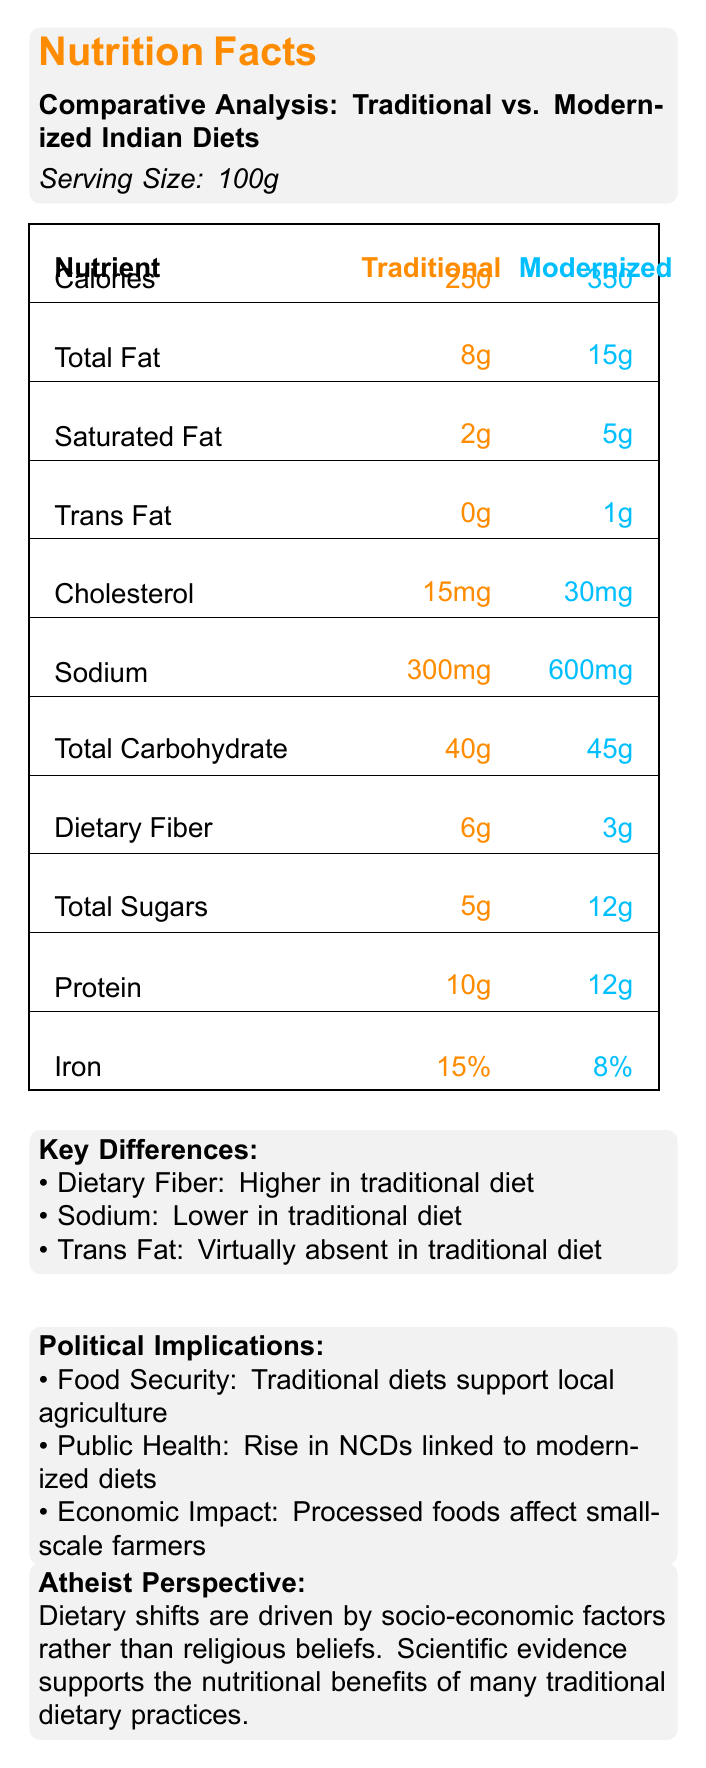what is the serving size for both diets? The document specifies that the serving size for both the traditional and modernized diets is 100g.
Answer: 100g how many calories are in the traditional diet per serving? The document states that the traditional diet contains 250 calories per serving.
Answer: 250 how much total fat is there in the modernized diet per serving? According to the document, the modernized diet contains 15g of total fat per serving.
Answer: 15g which diet has a higher dietary fiber content? The document indicates that the traditional diet has 6g of dietary fiber compared to 3g in the modernized diet.
Answer: Traditional diet what are the traditional dietary staples listed in the document? The document lists these as the traditional staples in the cultural context section.
Answer: Dal (lentils), Roti (whole wheat flatbread), Rice, Sabzi (vegetable curry) Which diet has more sodium? A. Traditional diet B. Modernized diet C. Both have equal amounts The modernized diet has 600mg of sodium compared to 300mg in the traditional diet.
Answer: B Which aspects does the document mention under political implications? A. Food Security, Public Health, Economic Impact B. Food Security, Cultural Impact, Educational Impact C. Public Health, Environmental Impact, Economic Impact The document discusses food security, public health, and economic impact under political implications.
Answer: A Does the modernized diet have any trans fat? The document states that the modernized diet contains 1g of trans fat.
Answer: Yes What is the main idea of the document? The document compares the nutritional content of traditional and modernized Indian diets, discusses the implications of dietary shifts, and presents relevant scientific and political insights.
Answer: The document provides a comparative analysis of the nutrient profiles in traditional vs. modernized Indian diets, highlighting key differences, cultural context, political implications, scientific perspectives, and notable studies on the topic. What year was the study "The Impact of Westernization on Indian Dietary Patterns" published? The year of publication is not visually presented in the rendered document content.
Answer: Cannot be determined which diet is described as virtually absent of trans fats? The document states that trans fats are virtually absent in the traditional diet.
Answer: Traditional diet how much protein is in the modernized diet per serving? The modernized diet contains 12g of protein per serving, as mentioned in the document.
Answer: 12g What is the percentage of Vitamin A in the traditional diet? According to the document, the traditional diet contains 15% of the daily value for Vitamin A per serving.
Answer: 15% What scientific evidence is mentioned about traditional dietary practices from an atheist perspective? The atheist perspective section mentions that scientific evidence supports the nutritional benefits of traditional dietary practices.
Answer: The document states that scientific evidence supports the nutritional benefits of many traditional dietary practices. how does the traditional diet support food security? The document indicates that traditional diets support food security by promoting local agriculture and reducing dependence on food imports.
Answer: It supports local agriculture and reduces import dependence. 